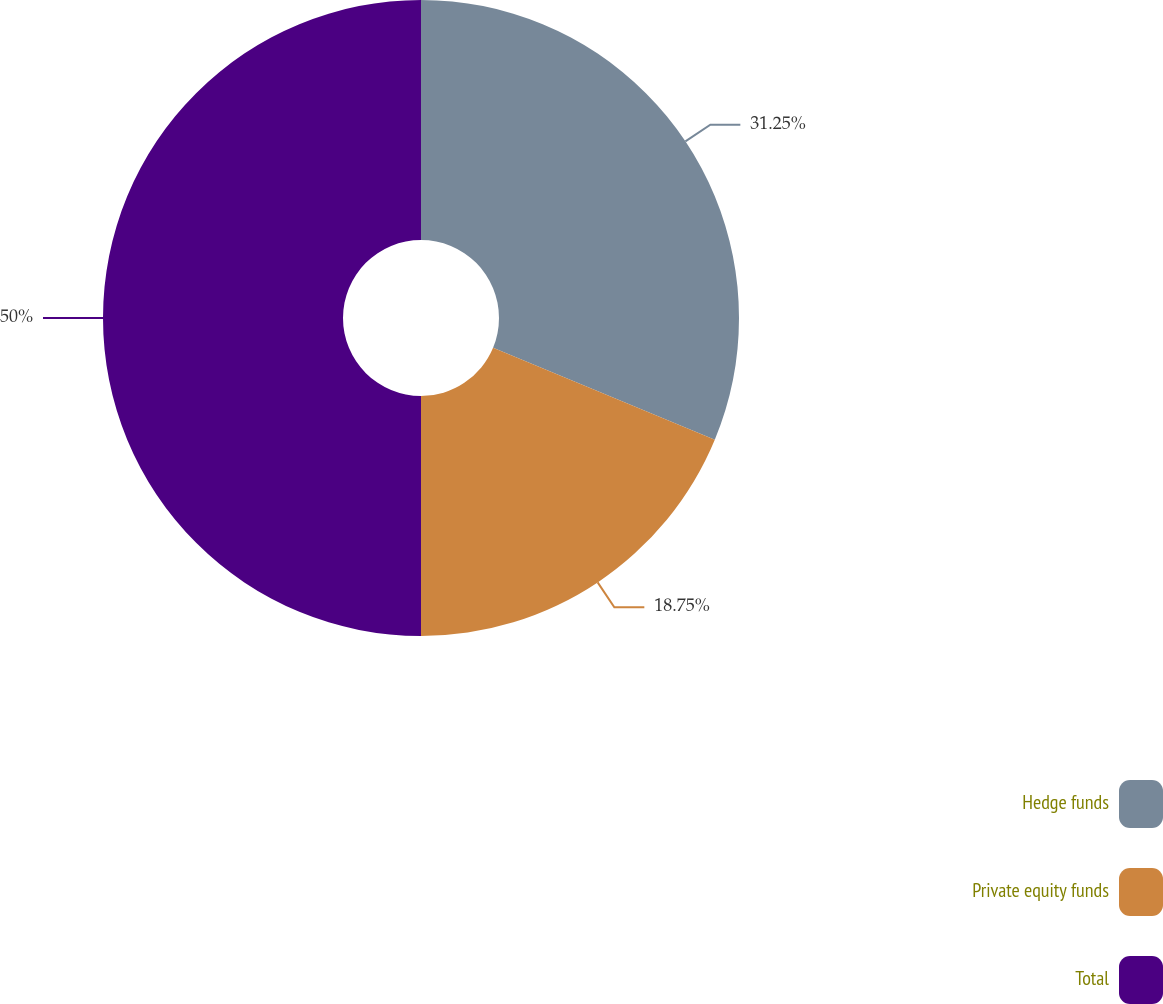Convert chart. <chart><loc_0><loc_0><loc_500><loc_500><pie_chart><fcel>Hedge funds<fcel>Private equity funds<fcel>Total<nl><fcel>31.25%<fcel>18.75%<fcel>50.0%<nl></chart> 